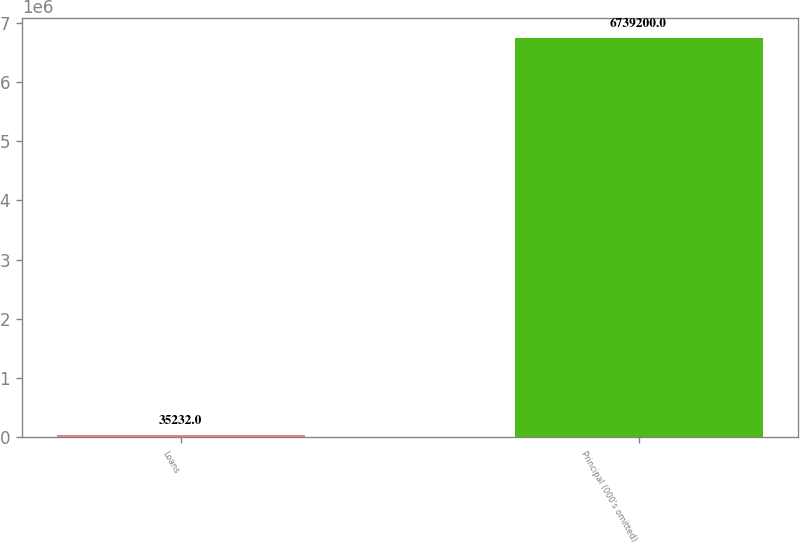Convert chart. <chart><loc_0><loc_0><loc_500><loc_500><bar_chart><fcel>Loans<fcel>Principal (000's omitted)<nl><fcel>35232<fcel>6.7392e+06<nl></chart> 